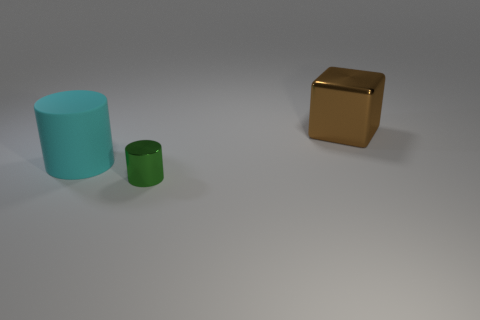Is the shape of the thing that is in front of the large cyan matte object the same as  the large cyan rubber thing?
Give a very brief answer. Yes. How many things are things that are in front of the big brown thing or objects to the left of the tiny green thing?
Ensure brevity in your answer.  2. There is a metallic object that is the same shape as the big cyan rubber thing; what color is it?
Ensure brevity in your answer.  Green. Is there anything else that is the same shape as the big brown object?
Give a very brief answer. No. Does the green shiny thing have the same shape as the big object in front of the large brown metallic block?
Provide a succinct answer. Yes. What is the material of the small cylinder?
Your answer should be very brief. Metal. There is another object that is the same shape as the small object; what size is it?
Your answer should be very brief. Large. What number of other objects are there of the same material as the green object?
Your answer should be very brief. 1. Do the big brown thing and the cylinder in front of the large matte cylinder have the same material?
Ensure brevity in your answer.  Yes. Are there fewer brown metallic blocks that are on the left side of the big brown thing than blocks that are to the right of the small green object?
Your answer should be very brief. Yes. 